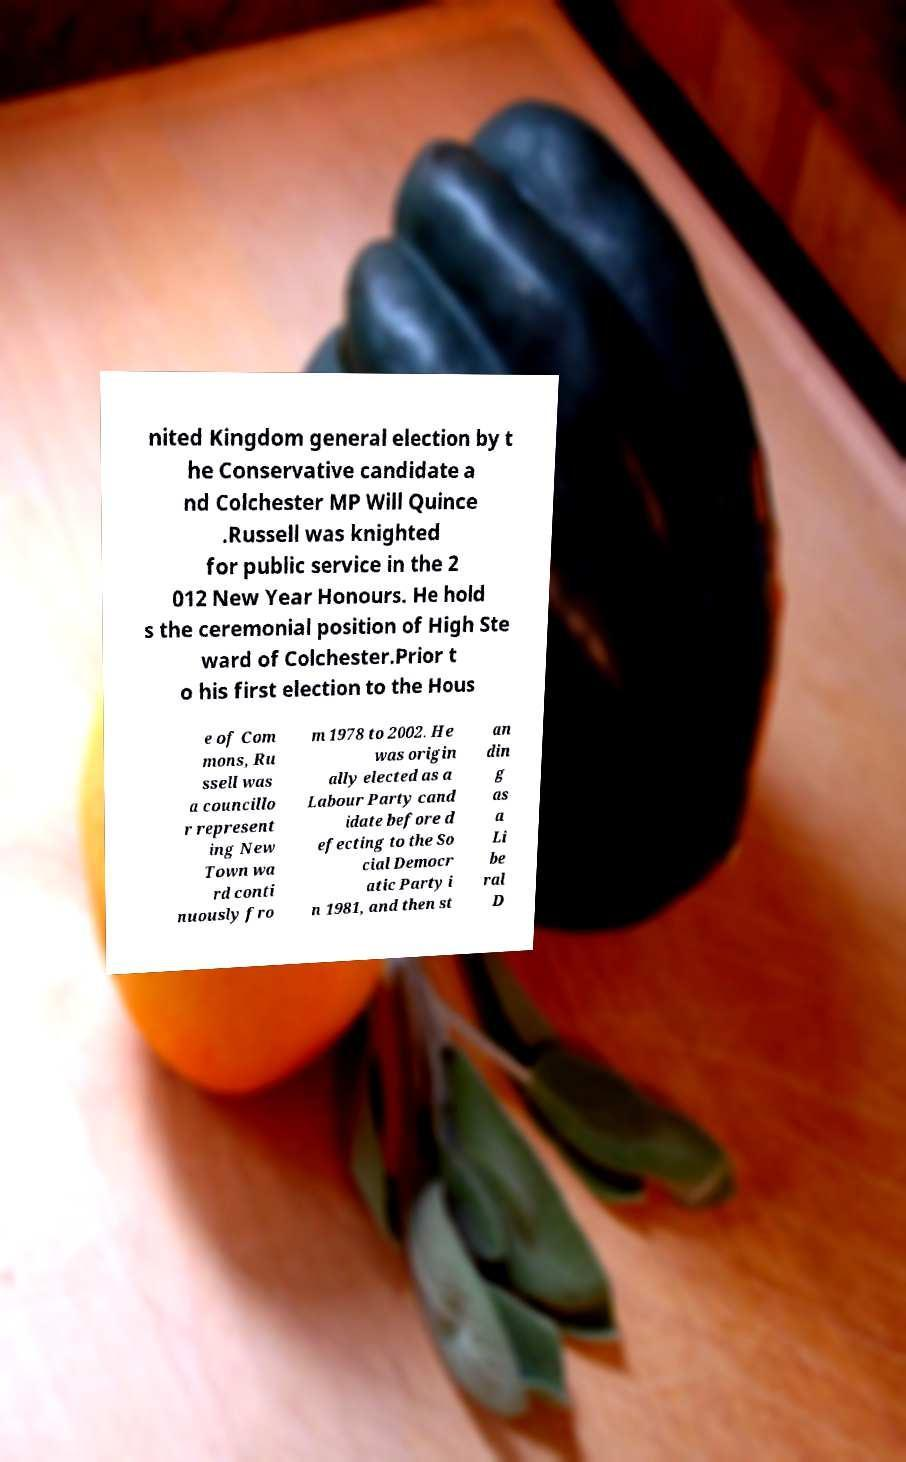Can you read and provide the text displayed in the image?This photo seems to have some interesting text. Can you extract and type it out for me? nited Kingdom general election by t he Conservative candidate a nd Colchester MP Will Quince .Russell was knighted for public service in the 2 012 New Year Honours. He hold s the ceremonial position of High Ste ward of Colchester.Prior t o his first election to the Hous e of Com mons, Ru ssell was a councillo r represent ing New Town wa rd conti nuously fro m 1978 to 2002. He was origin ally elected as a Labour Party cand idate before d efecting to the So cial Democr atic Party i n 1981, and then st an din g as a Li be ral D 